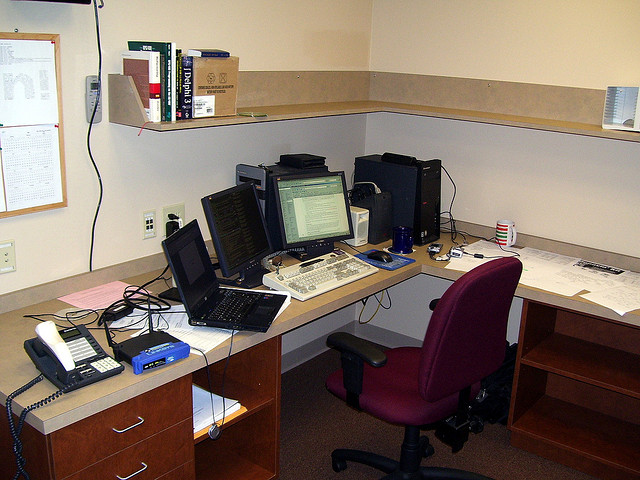Read all the text in this image. Delphi 